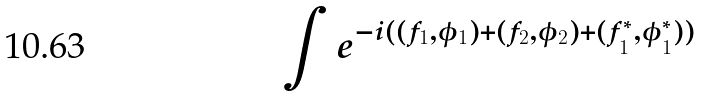<formula> <loc_0><loc_0><loc_500><loc_500>\int e ^ { - i ( ( f _ { 1 } , \phi _ { 1 } ) + ( f _ { 2 } , \phi _ { 2 } ) + ( f _ { 1 } ^ { * } , \phi _ { 1 } ^ { * } ) ) }</formula> 